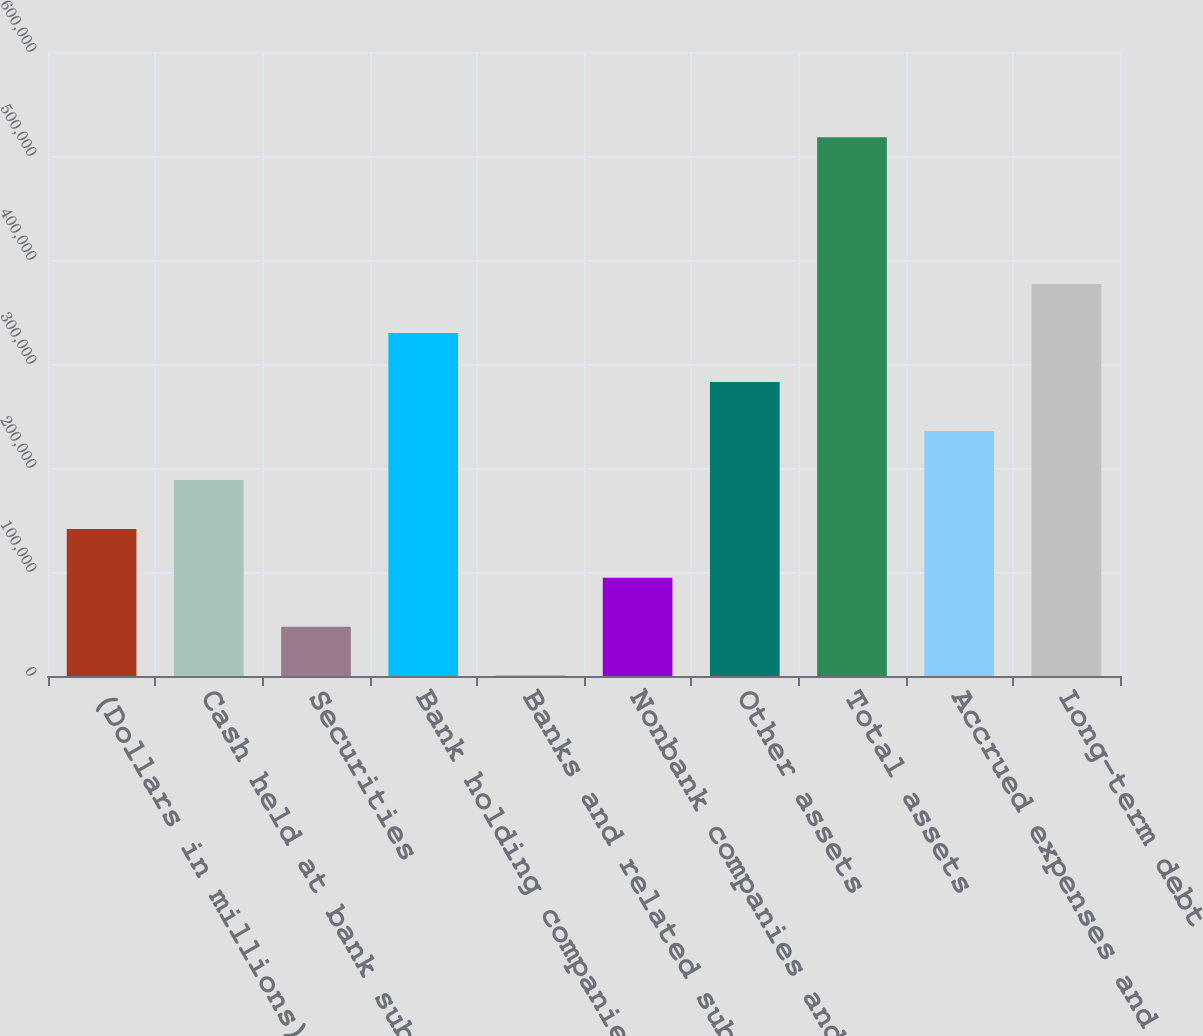<chart> <loc_0><loc_0><loc_500><loc_500><bar_chart><fcel>(Dollars in millions)<fcel>Cash held at bank subsidiaries<fcel>Securities<fcel>Bank holding companies and<fcel>Banks and related subsidiaries<fcel>Nonbank companies and related<fcel>Other assets<fcel>Total assets<fcel>Accrued expenses and other<fcel>Long-term debt<nl><fcel>141440<fcel>188521<fcel>47276.6<fcel>329766<fcel>195<fcel>94358.2<fcel>282685<fcel>518093<fcel>235603<fcel>376848<nl></chart> 